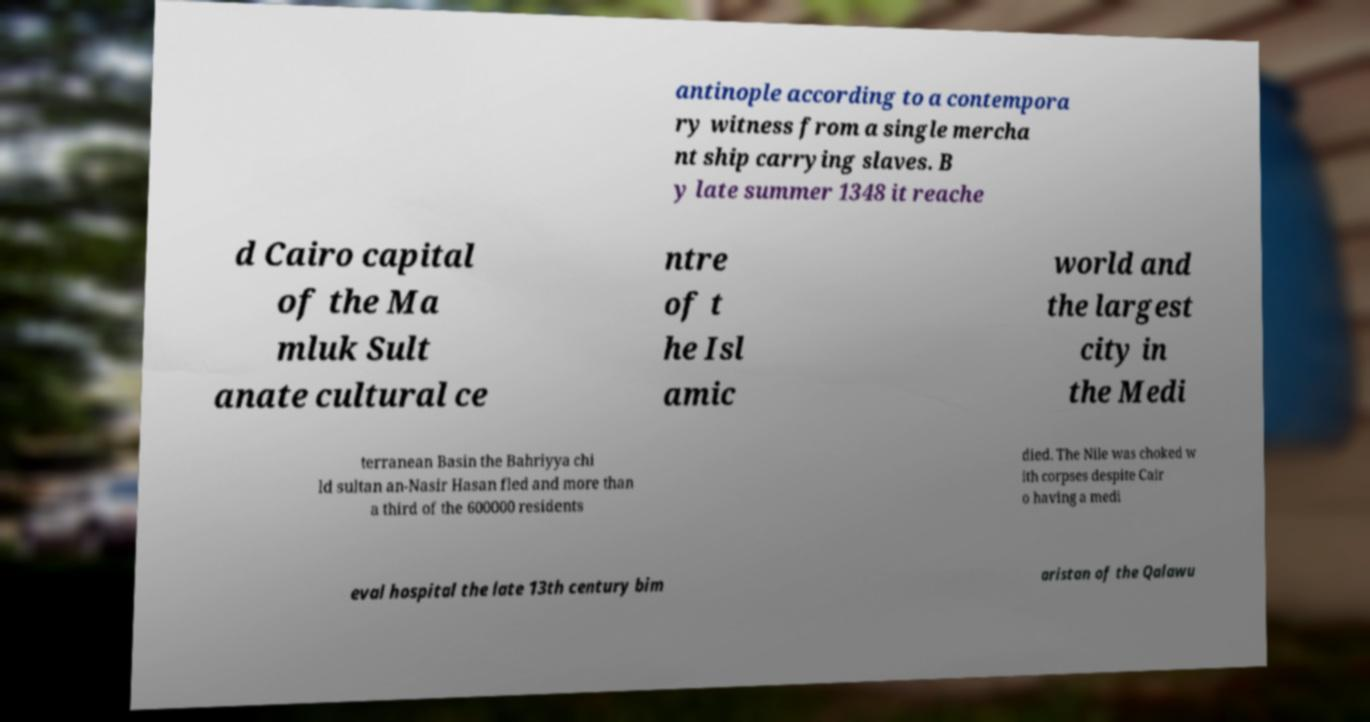Could you assist in decoding the text presented in this image and type it out clearly? antinople according to a contempora ry witness from a single mercha nt ship carrying slaves. B y late summer 1348 it reache d Cairo capital of the Ma mluk Sult anate cultural ce ntre of t he Isl amic world and the largest city in the Medi terranean Basin the Bahriyya chi ld sultan an-Nasir Hasan fled and more than a third of the 600000 residents died. The Nile was choked w ith corpses despite Cair o having a medi eval hospital the late 13th century bim aristan of the Qalawu 